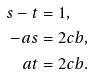Convert formula to latex. <formula><loc_0><loc_0><loc_500><loc_500>s - t & = 1 , \\ - a s & = 2 c b , \\ a t & = 2 c b .</formula> 